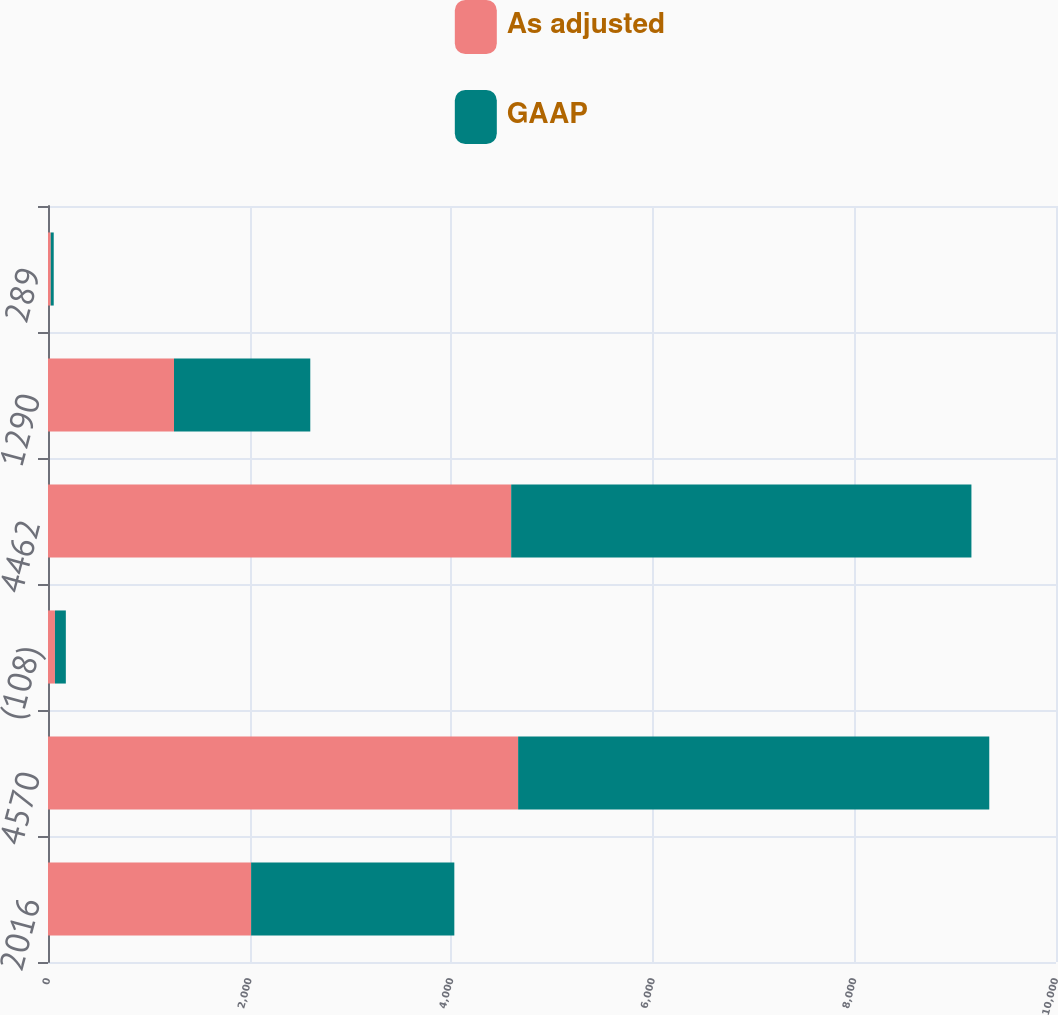<chart> <loc_0><loc_0><loc_500><loc_500><stacked_bar_chart><ecel><fcel>2016<fcel>4570<fcel>(108)<fcel>4462<fcel>1290<fcel>289<nl><fcel>As adjusted<fcel>2015<fcel>4664<fcel>69<fcel>4595<fcel>1250<fcel>27.2<nl><fcel>GAAP<fcel>2016<fcel>4674<fcel>108<fcel>4566<fcel>1352<fcel>29.6<nl></chart> 